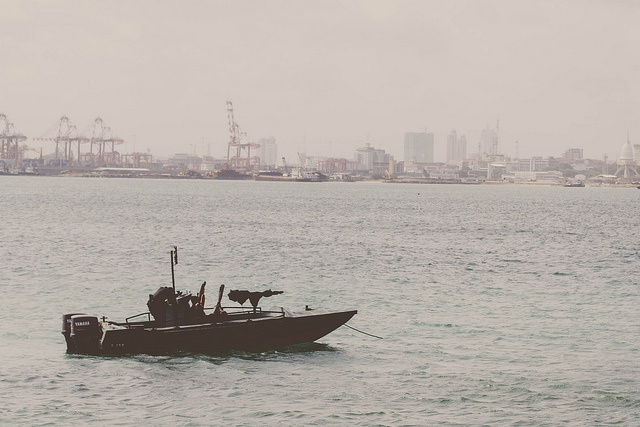Describe the objects in this image and their specific colors. I can see boat in lightgray, black, gray, and darkgray tones, boat in lightgray, darkgray, and gray tones, and boat in lightgray, darkgray, gray, and tan tones in this image. 